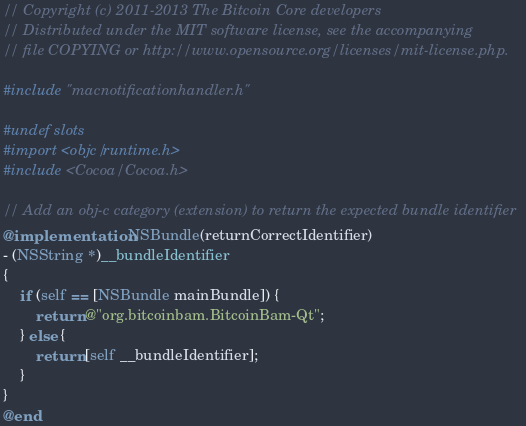<code> <loc_0><loc_0><loc_500><loc_500><_ObjectiveC_>// Copyright (c) 2011-2013 The Bitcoin Core developers
// Distributed under the MIT software license, see the accompanying
// file COPYING or http://www.opensource.org/licenses/mit-license.php.

#include "macnotificationhandler.h"

#undef slots
#import <objc/runtime.h>
#include <Cocoa/Cocoa.h>

// Add an obj-c category (extension) to return the expected bundle identifier
@implementation NSBundle(returnCorrectIdentifier)
- (NSString *)__bundleIdentifier
{
    if (self == [NSBundle mainBundle]) {
        return @"org.bitcoinbam.BitcoinBam-Qt";
    } else {
        return [self __bundleIdentifier];
    }
}
@end
</code> 